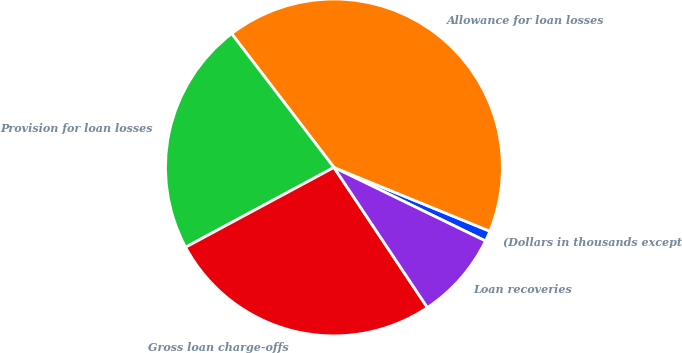Convert chart to OTSL. <chart><loc_0><loc_0><loc_500><loc_500><pie_chart><fcel>(Dollars in thousands except<fcel>Allowance for loan losses<fcel>Provision for loan losses<fcel>Gross loan charge-offs<fcel>Loan recoveries<nl><fcel>1.01%<fcel>41.57%<fcel>22.46%<fcel>26.51%<fcel>8.45%<nl></chart> 